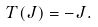Convert formula to latex. <formula><loc_0><loc_0><loc_500><loc_500>T ( J ) = - J .</formula> 